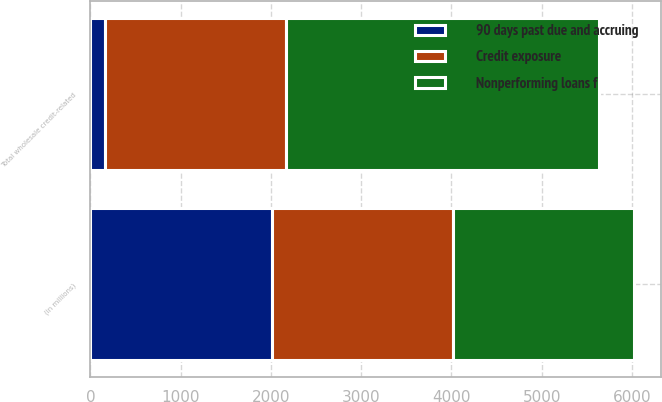Convert chart to OTSL. <chart><loc_0><loc_0><loc_500><loc_500><stacked_bar_chart><ecel><fcel>(in millions)<fcel>Total wholesale credit-related<nl><fcel>Credit exposure<fcel>2008<fcel>2008<nl><fcel>Nonperforming loans f<fcel>2008<fcel>3461<nl><fcel>90 days past due and accruing<fcel>2008<fcel>163<nl></chart> 